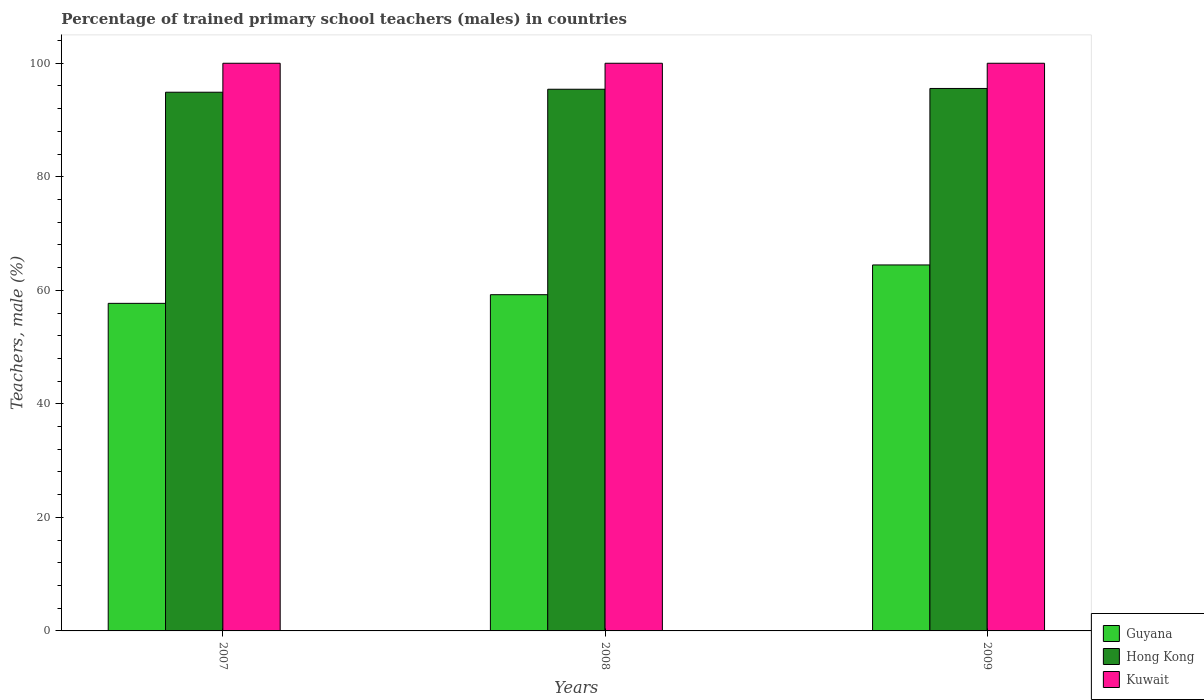How many bars are there on the 3rd tick from the left?
Your response must be concise. 3. How many bars are there on the 3rd tick from the right?
Your answer should be very brief. 3. In how many cases, is the number of bars for a given year not equal to the number of legend labels?
Your answer should be compact. 0. What is the percentage of trained primary school teachers (males) in Guyana in 2008?
Give a very brief answer. 59.23. Across all years, what is the maximum percentage of trained primary school teachers (males) in Guyana?
Give a very brief answer. 64.47. Across all years, what is the minimum percentage of trained primary school teachers (males) in Guyana?
Your answer should be very brief. 57.71. In which year was the percentage of trained primary school teachers (males) in Kuwait maximum?
Provide a short and direct response. 2007. What is the total percentage of trained primary school teachers (males) in Kuwait in the graph?
Keep it short and to the point. 300. What is the difference between the percentage of trained primary school teachers (males) in Hong Kong in 2007 and that in 2009?
Provide a succinct answer. -0.66. What is the difference between the percentage of trained primary school teachers (males) in Hong Kong in 2008 and the percentage of trained primary school teachers (males) in Kuwait in 2009?
Offer a terse response. -4.58. In the year 2009, what is the difference between the percentage of trained primary school teachers (males) in Kuwait and percentage of trained primary school teachers (males) in Guyana?
Ensure brevity in your answer.  35.53. What is the ratio of the percentage of trained primary school teachers (males) in Guyana in 2008 to that in 2009?
Make the answer very short. 0.92. Is the percentage of trained primary school teachers (males) in Guyana in 2007 less than that in 2008?
Provide a short and direct response. Yes. What is the difference between the highest and the second highest percentage of trained primary school teachers (males) in Hong Kong?
Ensure brevity in your answer.  0.14. What is the difference between the highest and the lowest percentage of trained primary school teachers (males) in Guyana?
Your answer should be very brief. 6.76. In how many years, is the percentage of trained primary school teachers (males) in Hong Kong greater than the average percentage of trained primary school teachers (males) in Hong Kong taken over all years?
Give a very brief answer. 2. Is the sum of the percentage of trained primary school teachers (males) in Kuwait in 2007 and 2009 greater than the maximum percentage of trained primary school teachers (males) in Guyana across all years?
Provide a short and direct response. Yes. What does the 2nd bar from the left in 2008 represents?
Your response must be concise. Hong Kong. What does the 2nd bar from the right in 2009 represents?
Offer a very short reply. Hong Kong. Is it the case that in every year, the sum of the percentage of trained primary school teachers (males) in Hong Kong and percentage of trained primary school teachers (males) in Guyana is greater than the percentage of trained primary school teachers (males) in Kuwait?
Your answer should be compact. Yes. Are all the bars in the graph horizontal?
Offer a terse response. No. Does the graph contain any zero values?
Provide a succinct answer. No. Does the graph contain grids?
Ensure brevity in your answer.  No. Where does the legend appear in the graph?
Keep it short and to the point. Bottom right. How many legend labels are there?
Provide a succinct answer. 3. What is the title of the graph?
Make the answer very short. Percentage of trained primary school teachers (males) in countries. What is the label or title of the Y-axis?
Your answer should be very brief. Teachers, male (%). What is the Teachers, male (%) in Guyana in 2007?
Your answer should be compact. 57.71. What is the Teachers, male (%) of Hong Kong in 2007?
Provide a short and direct response. 94.9. What is the Teachers, male (%) of Guyana in 2008?
Make the answer very short. 59.23. What is the Teachers, male (%) in Hong Kong in 2008?
Provide a short and direct response. 95.42. What is the Teachers, male (%) in Guyana in 2009?
Keep it short and to the point. 64.47. What is the Teachers, male (%) in Hong Kong in 2009?
Offer a terse response. 95.56. What is the Teachers, male (%) of Kuwait in 2009?
Give a very brief answer. 100. Across all years, what is the maximum Teachers, male (%) in Guyana?
Offer a terse response. 64.47. Across all years, what is the maximum Teachers, male (%) of Hong Kong?
Offer a very short reply. 95.56. Across all years, what is the minimum Teachers, male (%) of Guyana?
Your answer should be very brief. 57.71. Across all years, what is the minimum Teachers, male (%) of Hong Kong?
Your answer should be very brief. 94.9. Across all years, what is the minimum Teachers, male (%) in Kuwait?
Your answer should be very brief. 100. What is the total Teachers, male (%) in Guyana in the graph?
Make the answer very short. 181.41. What is the total Teachers, male (%) of Hong Kong in the graph?
Your response must be concise. 285.88. What is the total Teachers, male (%) in Kuwait in the graph?
Make the answer very short. 300. What is the difference between the Teachers, male (%) in Guyana in 2007 and that in 2008?
Offer a very short reply. -1.52. What is the difference between the Teachers, male (%) of Hong Kong in 2007 and that in 2008?
Offer a very short reply. -0.53. What is the difference between the Teachers, male (%) in Kuwait in 2007 and that in 2008?
Offer a very short reply. 0. What is the difference between the Teachers, male (%) of Guyana in 2007 and that in 2009?
Offer a very short reply. -6.76. What is the difference between the Teachers, male (%) of Hong Kong in 2007 and that in 2009?
Make the answer very short. -0.66. What is the difference between the Teachers, male (%) in Kuwait in 2007 and that in 2009?
Ensure brevity in your answer.  0. What is the difference between the Teachers, male (%) in Guyana in 2008 and that in 2009?
Offer a terse response. -5.24. What is the difference between the Teachers, male (%) of Hong Kong in 2008 and that in 2009?
Your answer should be very brief. -0.14. What is the difference between the Teachers, male (%) in Guyana in 2007 and the Teachers, male (%) in Hong Kong in 2008?
Your response must be concise. -37.72. What is the difference between the Teachers, male (%) of Guyana in 2007 and the Teachers, male (%) of Kuwait in 2008?
Your answer should be very brief. -42.29. What is the difference between the Teachers, male (%) of Hong Kong in 2007 and the Teachers, male (%) of Kuwait in 2008?
Your answer should be very brief. -5.1. What is the difference between the Teachers, male (%) of Guyana in 2007 and the Teachers, male (%) of Hong Kong in 2009?
Your answer should be very brief. -37.85. What is the difference between the Teachers, male (%) in Guyana in 2007 and the Teachers, male (%) in Kuwait in 2009?
Your answer should be compact. -42.29. What is the difference between the Teachers, male (%) in Hong Kong in 2007 and the Teachers, male (%) in Kuwait in 2009?
Your response must be concise. -5.1. What is the difference between the Teachers, male (%) of Guyana in 2008 and the Teachers, male (%) of Hong Kong in 2009?
Ensure brevity in your answer.  -36.33. What is the difference between the Teachers, male (%) of Guyana in 2008 and the Teachers, male (%) of Kuwait in 2009?
Provide a succinct answer. -40.77. What is the difference between the Teachers, male (%) of Hong Kong in 2008 and the Teachers, male (%) of Kuwait in 2009?
Keep it short and to the point. -4.58. What is the average Teachers, male (%) of Guyana per year?
Provide a succinct answer. 60.47. What is the average Teachers, male (%) in Hong Kong per year?
Give a very brief answer. 95.29. What is the average Teachers, male (%) of Kuwait per year?
Keep it short and to the point. 100. In the year 2007, what is the difference between the Teachers, male (%) in Guyana and Teachers, male (%) in Hong Kong?
Offer a very short reply. -37.19. In the year 2007, what is the difference between the Teachers, male (%) in Guyana and Teachers, male (%) in Kuwait?
Your answer should be very brief. -42.29. In the year 2007, what is the difference between the Teachers, male (%) in Hong Kong and Teachers, male (%) in Kuwait?
Your answer should be compact. -5.1. In the year 2008, what is the difference between the Teachers, male (%) of Guyana and Teachers, male (%) of Hong Kong?
Your answer should be compact. -36.19. In the year 2008, what is the difference between the Teachers, male (%) in Guyana and Teachers, male (%) in Kuwait?
Your response must be concise. -40.77. In the year 2008, what is the difference between the Teachers, male (%) in Hong Kong and Teachers, male (%) in Kuwait?
Provide a short and direct response. -4.58. In the year 2009, what is the difference between the Teachers, male (%) in Guyana and Teachers, male (%) in Hong Kong?
Make the answer very short. -31.09. In the year 2009, what is the difference between the Teachers, male (%) in Guyana and Teachers, male (%) in Kuwait?
Your answer should be compact. -35.53. In the year 2009, what is the difference between the Teachers, male (%) in Hong Kong and Teachers, male (%) in Kuwait?
Your answer should be compact. -4.44. What is the ratio of the Teachers, male (%) of Guyana in 2007 to that in 2008?
Offer a very short reply. 0.97. What is the ratio of the Teachers, male (%) in Hong Kong in 2007 to that in 2008?
Offer a terse response. 0.99. What is the ratio of the Teachers, male (%) in Guyana in 2007 to that in 2009?
Offer a very short reply. 0.9. What is the ratio of the Teachers, male (%) in Hong Kong in 2007 to that in 2009?
Your response must be concise. 0.99. What is the ratio of the Teachers, male (%) of Guyana in 2008 to that in 2009?
Offer a very short reply. 0.92. What is the ratio of the Teachers, male (%) of Hong Kong in 2008 to that in 2009?
Your answer should be compact. 1. What is the difference between the highest and the second highest Teachers, male (%) of Guyana?
Your answer should be compact. 5.24. What is the difference between the highest and the second highest Teachers, male (%) of Hong Kong?
Keep it short and to the point. 0.14. What is the difference between the highest and the second highest Teachers, male (%) in Kuwait?
Keep it short and to the point. 0. What is the difference between the highest and the lowest Teachers, male (%) of Guyana?
Your answer should be compact. 6.76. What is the difference between the highest and the lowest Teachers, male (%) of Hong Kong?
Provide a short and direct response. 0.66. 